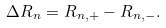Convert formula to latex. <formula><loc_0><loc_0><loc_500><loc_500>\Delta R _ { n } = R _ { n , + } - R _ { n , - } .</formula> 